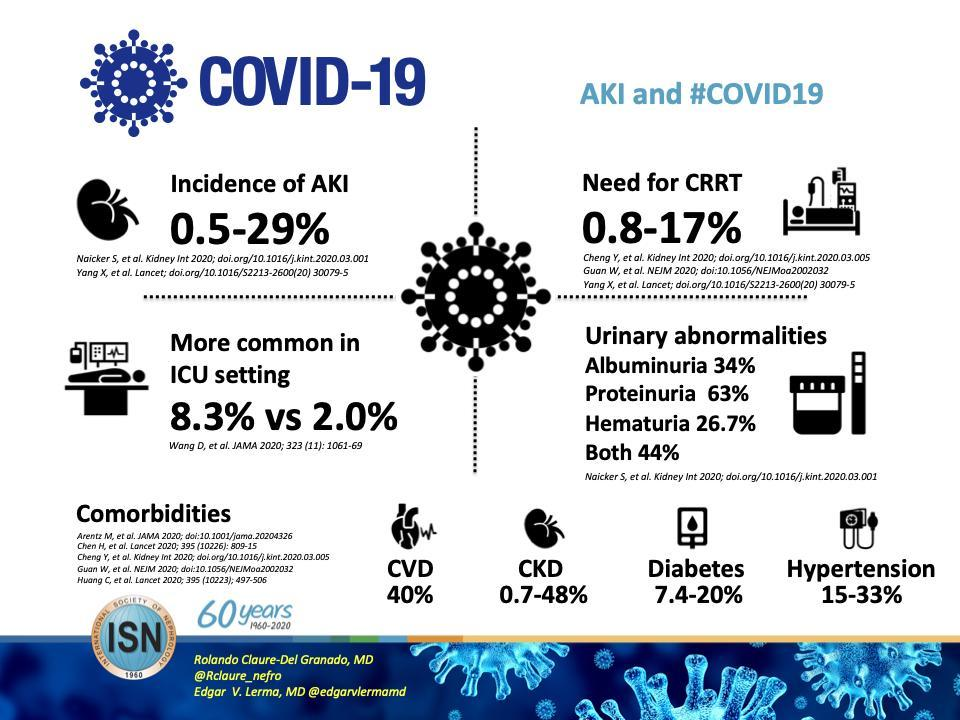which condition in urinary abnormalities show the highest proportion among the given conditions?
Answer the question with a short phrase. proteinuria what is the name of the journal where the urinary abnormalities after covid-19 is cited? kidney international In how many journlas the incidence of AKI is cited, 4 or 2? two 